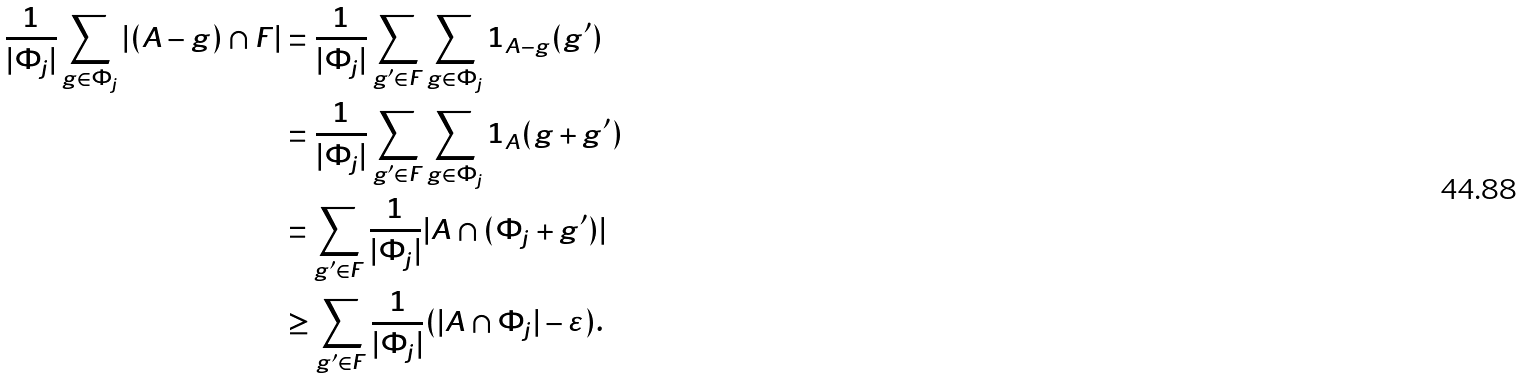Convert formula to latex. <formula><loc_0><loc_0><loc_500><loc_500>\frac { 1 } { | \Phi _ { j } | } \sum _ { g \in \Phi _ { j } } | ( A - g ) \cap F | & = \frac { 1 } { | \Phi _ { j } | } \sum _ { g ^ { \prime } \in F } \sum _ { g \in \Phi _ { j } } 1 _ { A - g } ( g ^ { \prime } ) \\ & = \frac { 1 } { | \Phi _ { j } | } \sum _ { g ^ { \prime } \in F } \sum _ { g \in \Phi _ { j } } 1 _ { A } ( g + g ^ { \prime } ) \\ & = \sum _ { g ^ { \prime } \in F } \frac { 1 } { | \Phi _ { j } | } | A \cap ( \Phi _ { j } + g ^ { \prime } ) | \\ & \geq \sum _ { g ^ { \prime } \in F } \frac { 1 } { | \Phi _ { j } | } ( | A \cap \Phi _ { j } | - \varepsilon ) .</formula> 